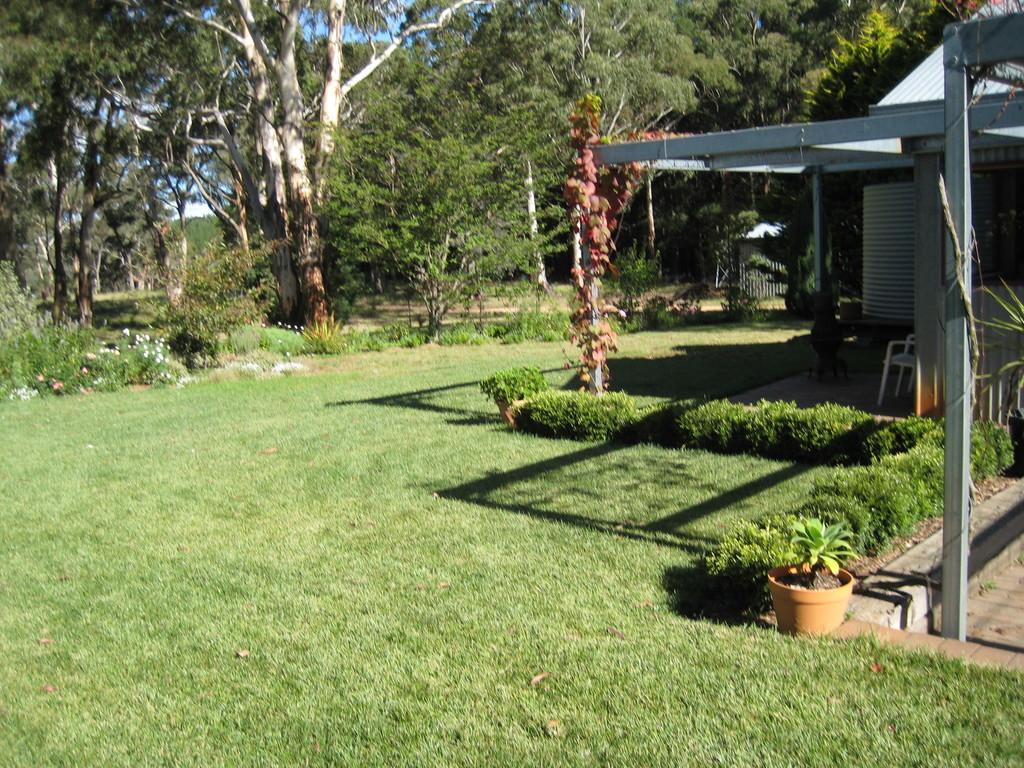Describe this image in one or two sentences. In this image I can see trees. There is grass, building, gate , there are plants and there are chairs. There are flowers and in the background there is sky. 